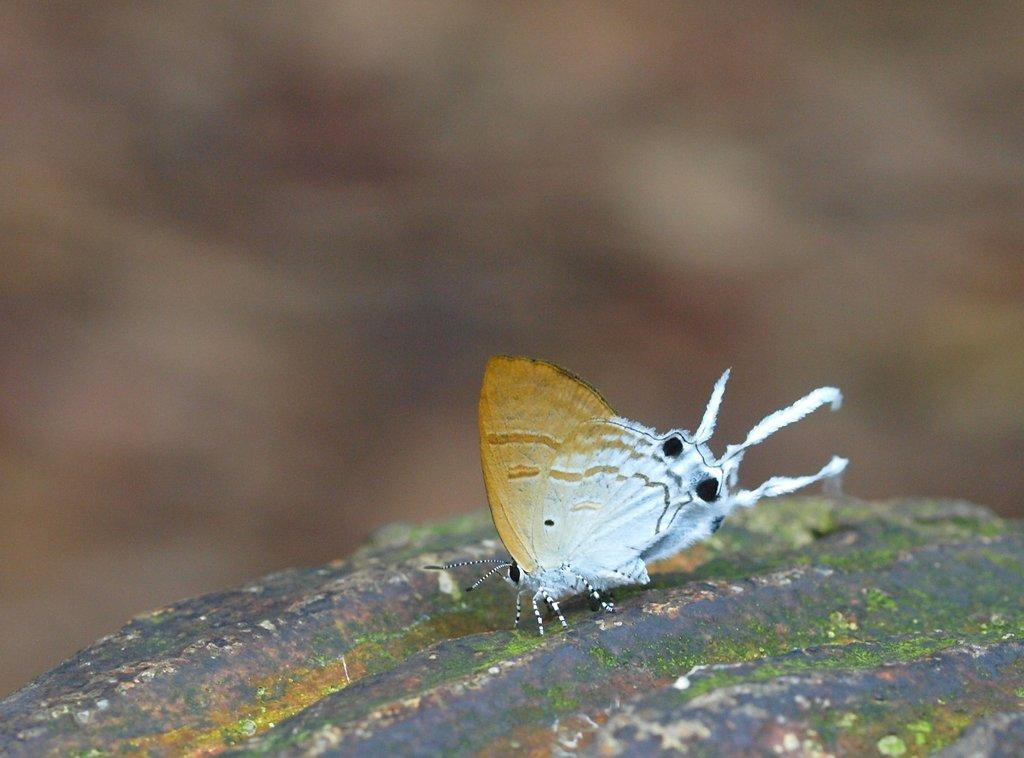What type of creature is present in the image? There is a butterfly in the image. Can you describe the colors of the butterfly? The butterfly has brown and white colors. Are there any chickens in the garden depicted in the image? There is no garden or chickens present in the image; it only features a butterfly with brown and white colors. 